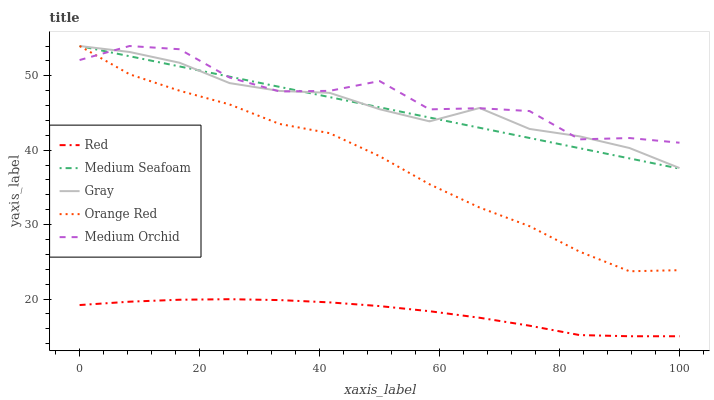Does Red have the minimum area under the curve?
Answer yes or no. Yes. Does Medium Orchid have the maximum area under the curve?
Answer yes or no. Yes. Does Medium Seafoam have the minimum area under the curve?
Answer yes or no. No. Does Medium Seafoam have the maximum area under the curve?
Answer yes or no. No. Is Medium Seafoam the smoothest?
Answer yes or no. Yes. Is Medium Orchid the roughest?
Answer yes or no. Yes. Is Medium Orchid the smoothest?
Answer yes or no. No. Is Medium Seafoam the roughest?
Answer yes or no. No. Does Red have the lowest value?
Answer yes or no. Yes. Does Medium Seafoam have the lowest value?
Answer yes or no. No. Does Orange Red have the highest value?
Answer yes or no. Yes. Does Red have the highest value?
Answer yes or no. No. Is Red less than Medium Seafoam?
Answer yes or no. Yes. Is Orange Red greater than Red?
Answer yes or no. Yes. Does Orange Red intersect Medium Orchid?
Answer yes or no. Yes. Is Orange Red less than Medium Orchid?
Answer yes or no. No. Is Orange Red greater than Medium Orchid?
Answer yes or no. No. Does Red intersect Medium Seafoam?
Answer yes or no. No. 